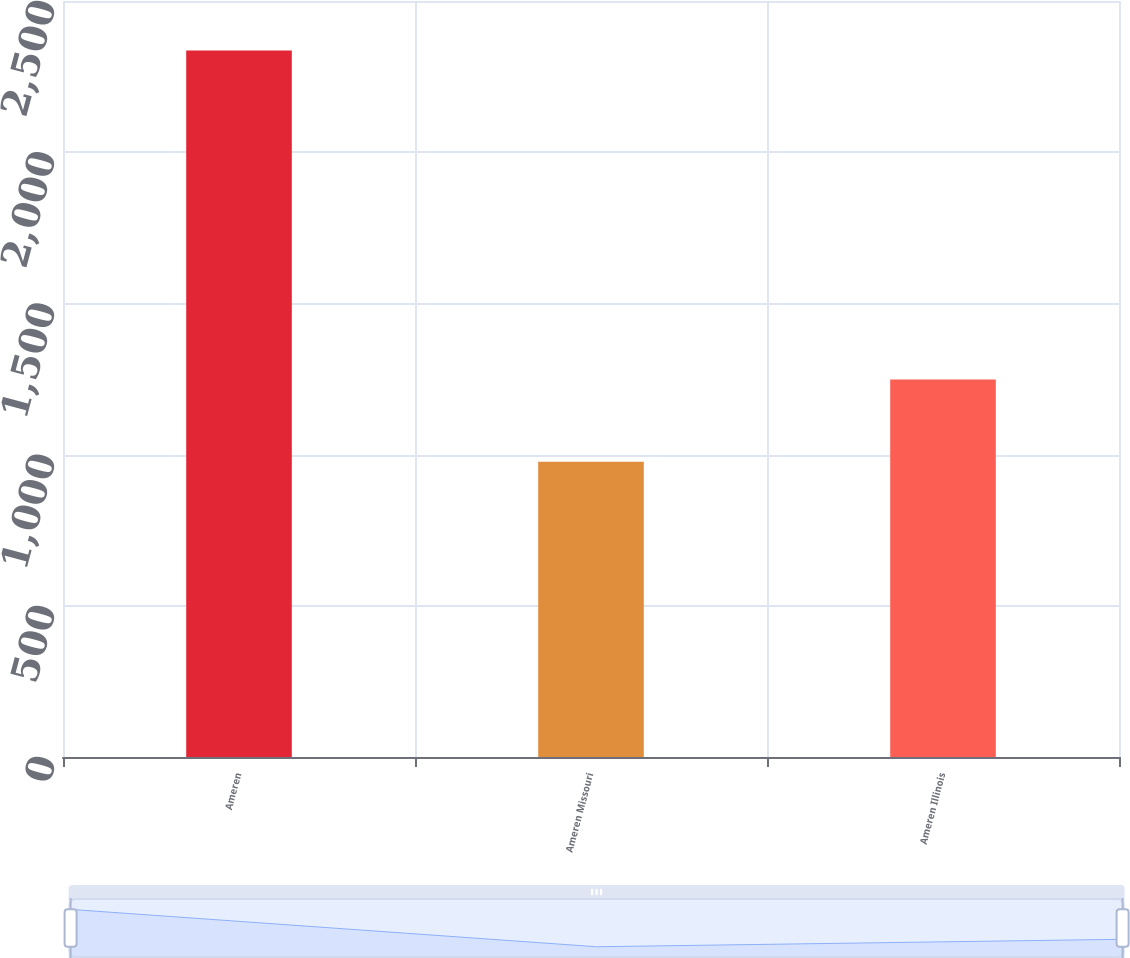<chart> <loc_0><loc_0><loc_500><loc_500><bar_chart><fcel>Ameren<fcel>Ameren Missouri<fcel>Ameren Illinois<nl><fcel>2336<fcel>976<fcel>1248<nl></chart> 